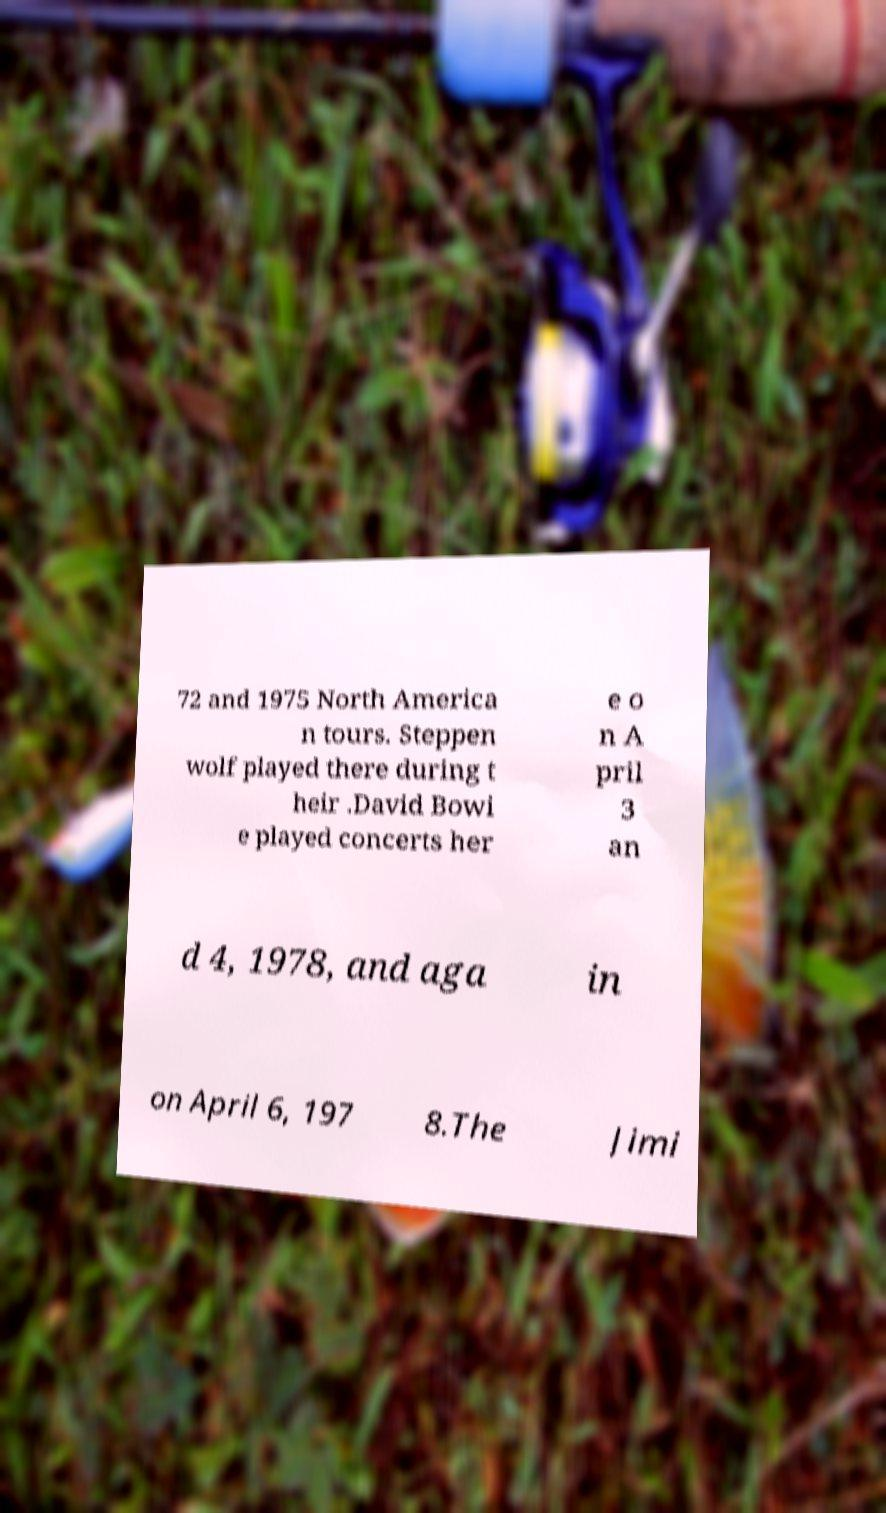Could you assist in decoding the text presented in this image and type it out clearly? 72 and 1975 North America n tours. Steppen wolf played there during t heir .David Bowi e played concerts her e o n A pril 3 an d 4, 1978, and aga in on April 6, 197 8.The Jimi 